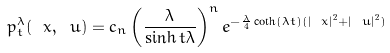<formula> <loc_0><loc_0><loc_500><loc_500>p _ { t } ^ { \lambda } ( \ x , \ u ) = c _ { n } \left ( \frac { \lambda } { \sinh t \lambda } \right ) ^ { n } e ^ { - \frac { \lambda } { 4 } \coth ( \lambda t ) ( | \ x | ^ { 2 } + | \ u | ^ { 2 } ) }</formula> 